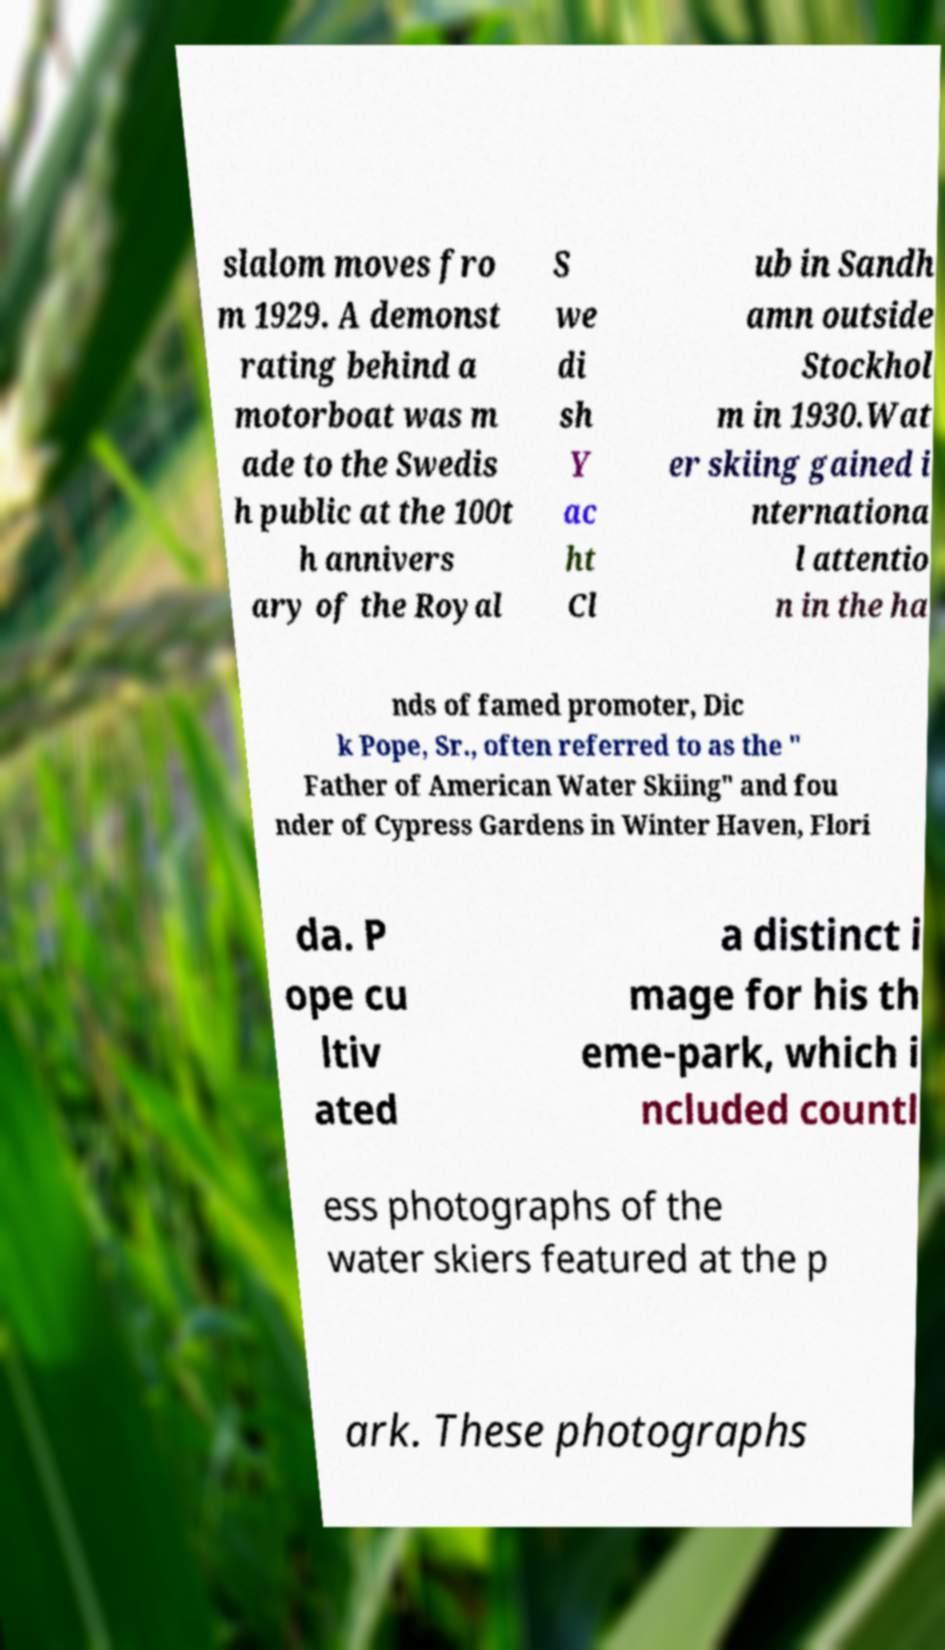There's text embedded in this image that I need extracted. Can you transcribe it verbatim? slalom moves fro m 1929. A demonst rating behind a motorboat was m ade to the Swedis h public at the 100t h annivers ary of the Royal S we di sh Y ac ht Cl ub in Sandh amn outside Stockhol m in 1930.Wat er skiing gained i nternationa l attentio n in the ha nds of famed promoter, Dic k Pope, Sr., often referred to as the " Father of American Water Skiing" and fou nder of Cypress Gardens in Winter Haven, Flori da. P ope cu ltiv ated a distinct i mage for his th eme-park, which i ncluded countl ess photographs of the water skiers featured at the p ark. These photographs 